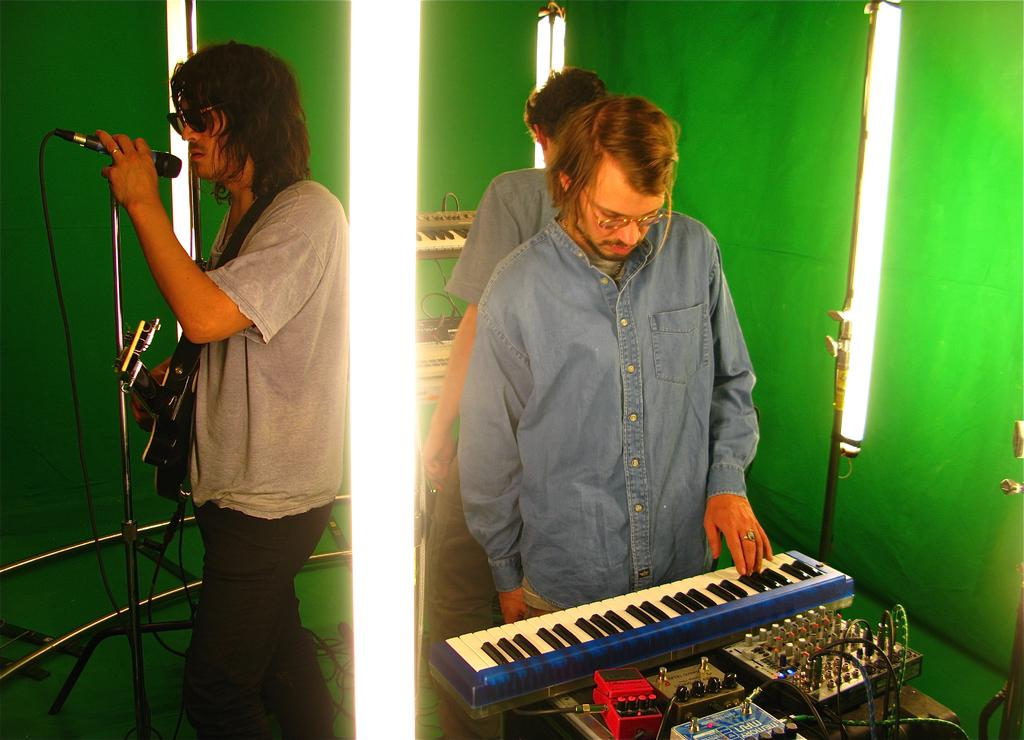How many men are in the image? There are three men in the image. What is one man doing in the image? One man is playing a piano. Where is the man standing on the right side? The man standing on the right side is not specified in the facts. What is the man on the left side doing? The man on the left side is singing in front of a microphone. What can be seen in the background of the image? There is a light in the background of the image. What type of government is depicted in the image? There is no reference to a government in the image; it features three men, one playing a piano, and another singing in front of a microphone. Can you tell me how many quince trees are in the image? There is no mention of quince trees in the image; it only features a light in the background. 